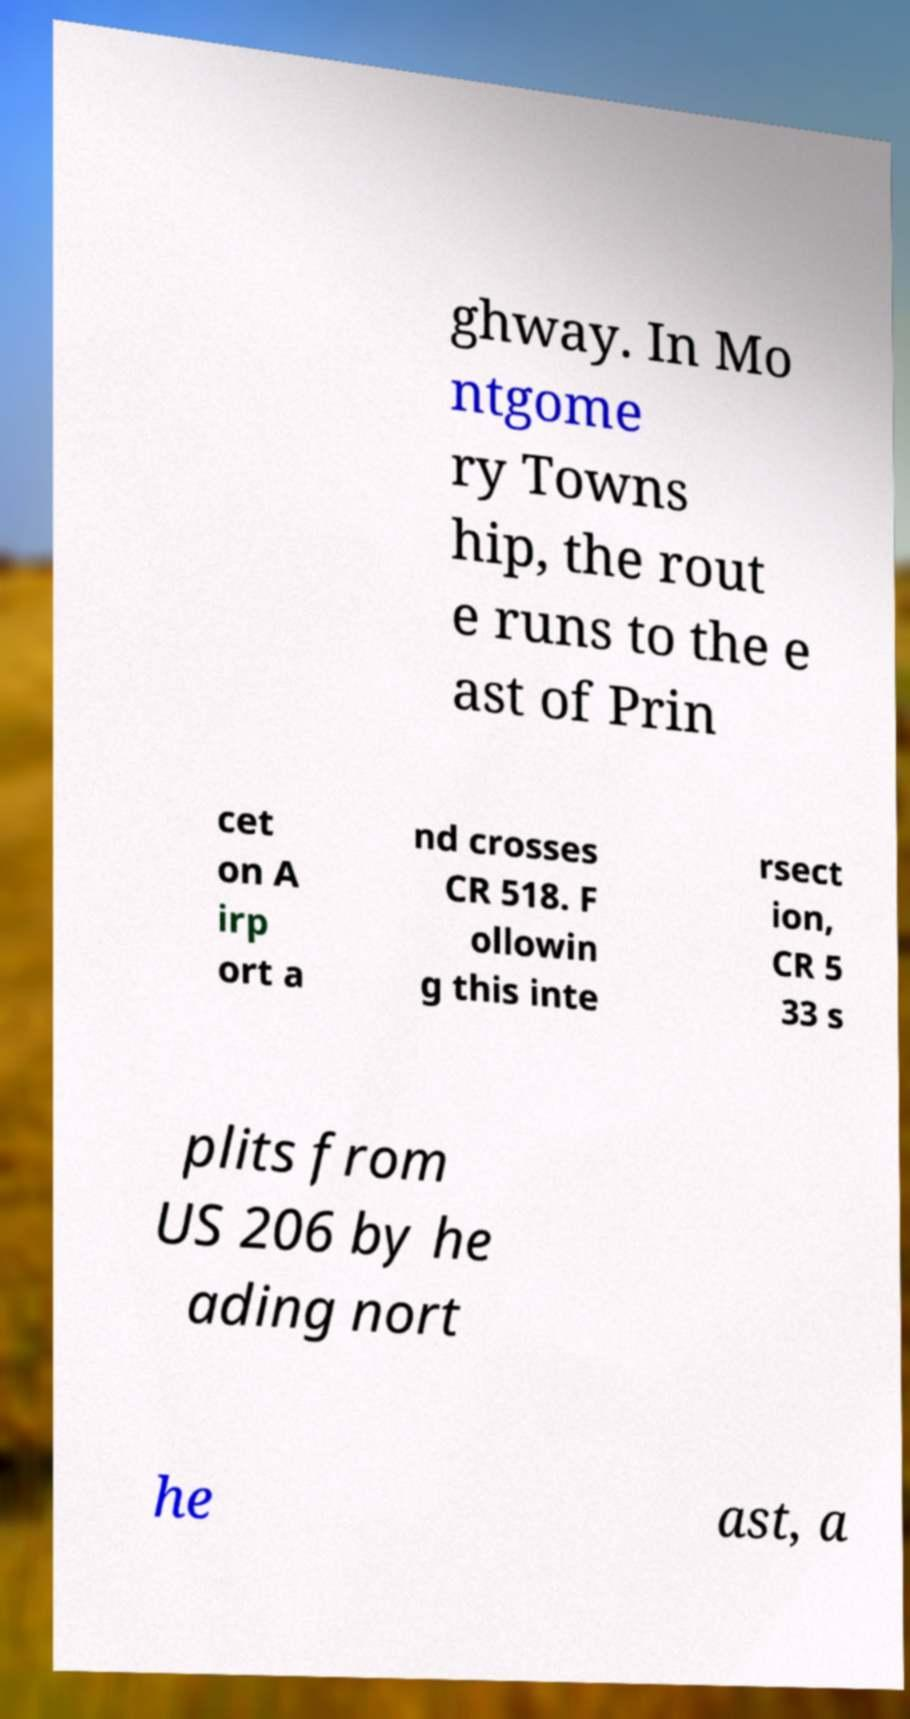Please read and relay the text visible in this image. What does it say? ghway. In Mo ntgome ry Towns hip, the rout e runs to the e ast of Prin cet on A irp ort a nd crosses CR 518. F ollowin g this inte rsect ion, CR 5 33 s plits from US 206 by he ading nort he ast, a 